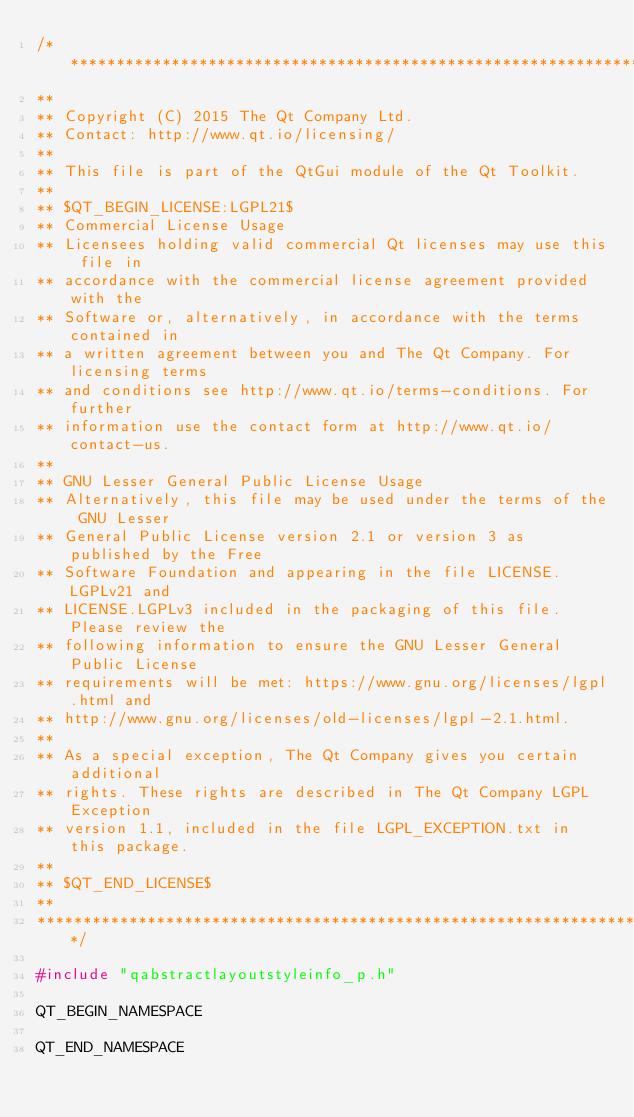Convert code to text. <code><loc_0><loc_0><loc_500><loc_500><_C++_>/****************************************************************************
**
** Copyright (C) 2015 The Qt Company Ltd.
** Contact: http://www.qt.io/licensing/
**
** This file is part of the QtGui module of the Qt Toolkit.
**
** $QT_BEGIN_LICENSE:LGPL21$
** Commercial License Usage
** Licensees holding valid commercial Qt licenses may use this file in
** accordance with the commercial license agreement provided with the
** Software or, alternatively, in accordance with the terms contained in
** a written agreement between you and The Qt Company. For licensing terms
** and conditions see http://www.qt.io/terms-conditions. For further
** information use the contact form at http://www.qt.io/contact-us.
**
** GNU Lesser General Public License Usage
** Alternatively, this file may be used under the terms of the GNU Lesser
** General Public License version 2.1 or version 3 as published by the Free
** Software Foundation and appearing in the file LICENSE.LGPLv21 and
** LICENSE.LGPLv3 included in the packaging of this file. Please review the
** following information to ensure the GNU Lesser General Public License
** requirements will be met: https://www.gnu.org/licenses/lgpl.html and
** http://www.gnu.org/licenses/old-licenses/lgpl-2.1.html.
**
** As a special exception, The Qt Company gives you certain additional
** rights. These rights are described in The Qt Company LGPL Exception
** version 1.1, included in the file LGPL_EXCEPTION.txt in this package.
**
** $QT_END_LICENSE$
**
****************************************************************************/

#include "qabstractlayoutstyleinfo_p.h"

QT_BEGIN_NAMESPACE

QT_END_NAMESPACE
</code> 